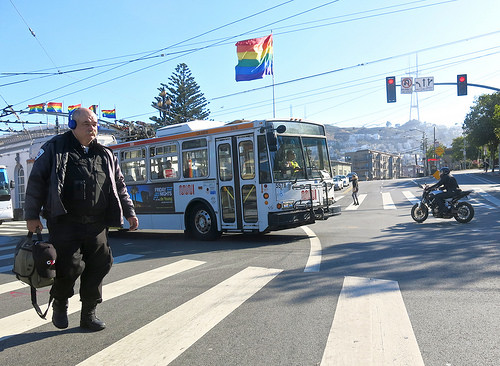<image>
Is there a crosswalk under the bus? No. The crosswalk is not positioned under the bus. The vertical relationship between these objects is different. Is the bus behind the man? Yes. From this viewpoint, the bus is positioned behind the man, with the man partially or fully occluding the bus. Is the man behind the flag? No. The man is not behind the flag. From this viewpoint, the man appears to be positioned elsewhere in the scene. 